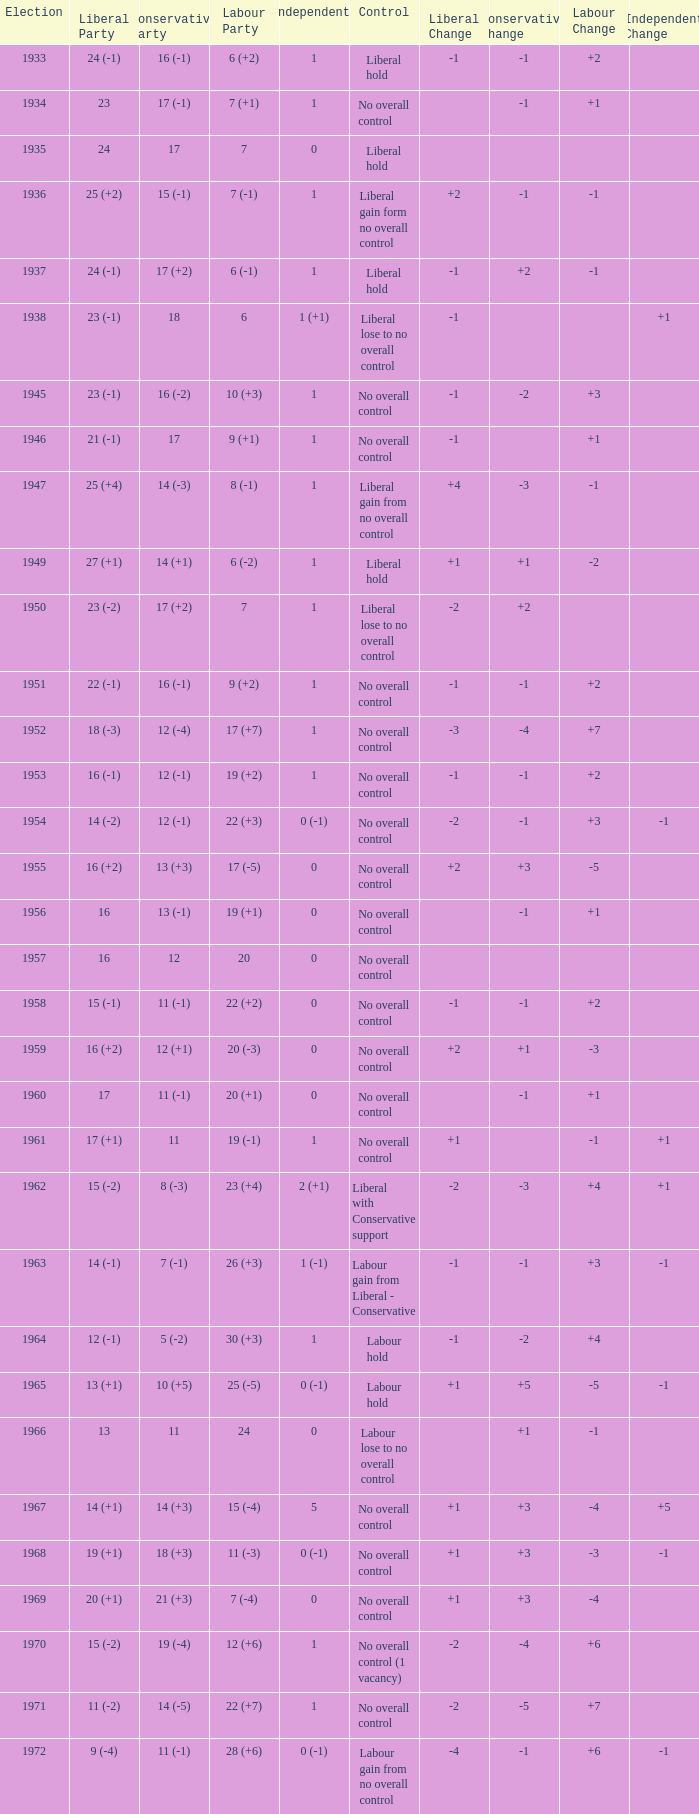What was the control for the year with a Conservative Party result of 10 (+5)? Labour hold. 